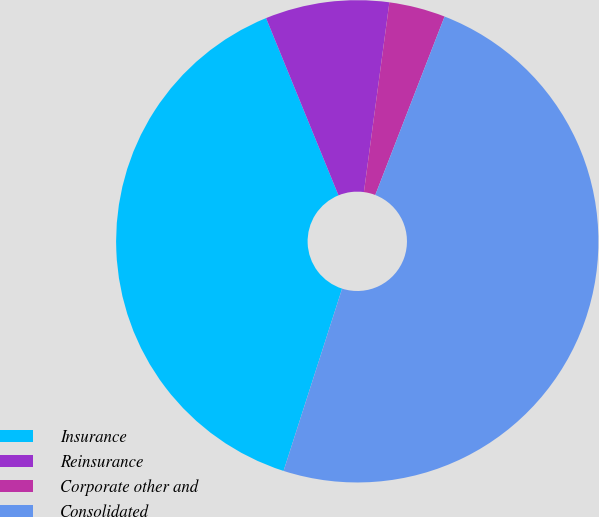Convert chart. <chart><loc_0><loc_0><loc_500><loc_500><pie_chart><fcel>Insurance<fcel>Reinsurance<fcel>Corporate other and<fcel>Consolidated<nl><fcel>38.88%<fcel>8.3%<fcel>3.77%<fcel>49.05%<nl></chart> 